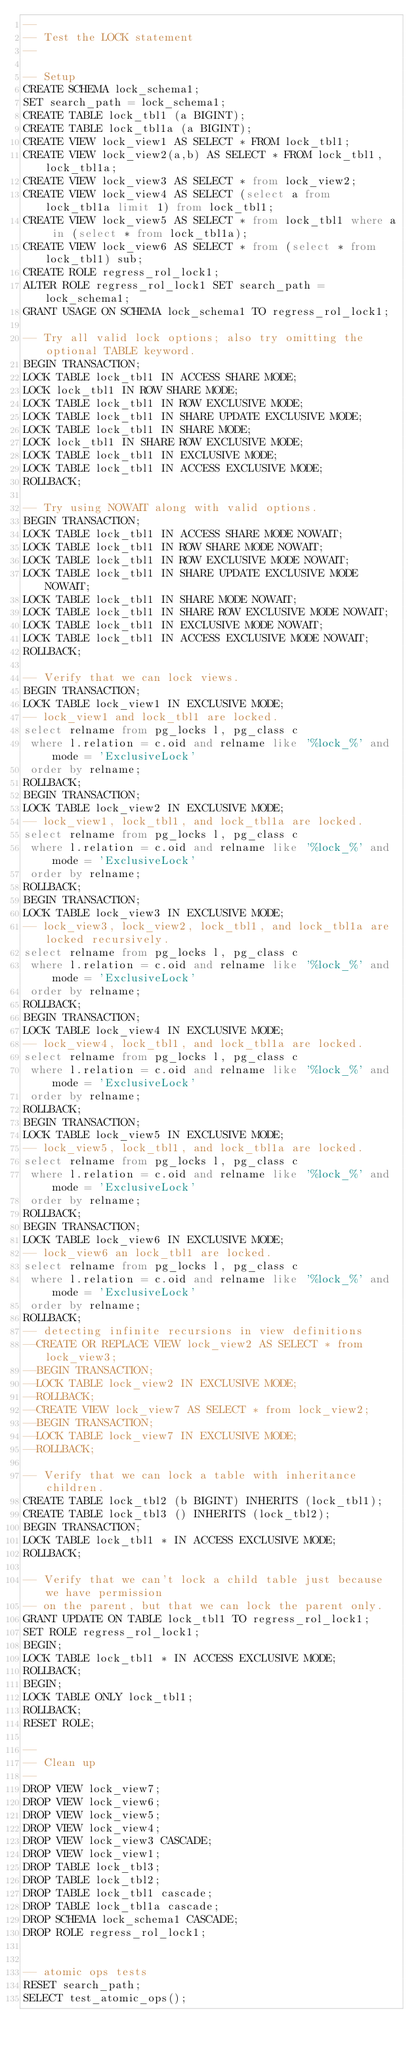Convert code to text. <code><loc_0><loc_0><loc_500><loc_500><_SQL_>--
-- Test the LOCK statement
--

-- Setup
CREATE SCHEMA lock_schema1;
SET search_path = lock_schema1;
CREATE TABLE lock_tbl1 (a BIGINT);
CREATE TABLE lock_tbl1a (a BIGINT);
CREATE VIEW lock_view1 AS SELECT * FROM lock_tbl1;
CREATE VIEW lock_view2(a,b) AS SELECT * FROM lock_tbl1, lock_tbl1a;
CREATE VIEW lock_view3 AS SELECT * from lock_view2;
CREATE VIEW lock_view4 AS SELECT (select a from lock_tbl1a limit 1) from lock_tbl1;
CREATE VIEW lock_view5 AS SELECT * from lock_tbl1 where a in (select * from lock_tbl1a);
CREATE VIEW lock_view6 AS SELECT * from (select * from lock_tbl1) sub;
CREATE ROLE regress_rol_lock1;
ALTER ROLE regress_rol_lock1 SET search_path = lock_schema1;
GRANT USAGE ON SCHEMA lock_schema1 TO regress_rol_lock1;

-- Try all valid lock options; also try omitting the optional TABLE keyword.
BEGIN TRANSACTION;
LOCK TABLE lock_tbl1 IN ACCESS SHARE MODE;
LOCK lock_tbl1 IN ROW SHARE MODE;
LOCK TABLE lock_tbl1 IN ROW EXCLUSIVE MODE;
LOCK TABLE lock_tbl1 IN SHARE UPDATE EXCLUSIVE MODE;
LOCK TABLE lock_tbl1 IN SHARE MODE;
LOCK lock_tbl1 IN SHARE ROW EXCLUSIVE MODE;
LOCK TABLE lock_tbl1 IN EXCLUSIVE MODE;
LOCK TABLE lock_tbl1 IN ACCESS EXCLUSIVE MODE;
ROLLBACK;

-- Try using NOWAIT along with valid options.
BEGIN TRANSACTION;
LOCK TABLE lock_tbl1 IN ACCESS SHARE MODE NOWAIT;
LOCK TABLE lock_tbl1 IN ROW SHARE MODE NOWAIT;
LOCK TABLE lock_tbl1 IN ROW EXCLUSIVE MODE NOWAIT;
LOCK TABLE lock_tbl1 IN SHARE UPDATE EXCLUSIVE MODE NOWAIT;
LOCK TABLE lock_tbl1 IN SHARE MODE NOWAIT;
LOCK TABLE lock_tbl1 IN SHARE ROW EXCLUSIVE MODE NOWAIT;
LOCK TABLE lock_tbl1 IN EXCLUSIVE MODE NOWAIT;
LOCK TABLE lock_tbl1 IN ACCESS EXCLUSIVE MODE NOWAIT;
ROLLBACK;

-- Verify that we can lock views.
BEGIN TRANSACTION;
LOCK TABLE lock_view1 IN EXCLUSIVE MODE;
-- lock_view1 and lock_tbl1 are locked.
select relname from pg_locks l, pg_class c
 where l.relation = c.oid and relname like '%lock_%' and mode = 'ExclusiveLock'
 order by relname;
ROLLBACK;
BEGIN TRANSACTION;
LOCK TABLE lock_view2 IN EXCLUSIVE MODE;
-- lock_view1, lock_tbl1, and lock_tbl1a are locked.
select relname from pg_locks l, pg_class c
 where l.relation = c.oid and relname like '%lock_%' and mode = 'ExclusiveLock'
 order by relname;
ROLLBACK;
BEGIN TRANSACTION;
LOCK TABLE lock_view3 IN EXCLUSIVE MODE;
-- lock_view3, lock_view2, lock_tbl1, and lock_tbl1a are locked recursively.
select relname from pg_locks l, pg_class c
 where l.relation = c.oid and relname like '%lock_%' and mode = 'ExclusiveLock'
 order by relname;
ROLLBACK;
BEGIN TRANSACTION;
LOCK TABLE lock_view4 IN EXCLUSIVE MODE;
-- lock_view4, lock_tbl1, and lock_tbl1a are locked.
select relname from pg_locks l, pg_class c
 where l.relation = c.oid and relname like '%lock_%' and mode = 'ExclusiveLock'
 order by relname;
ROLLBACK;
BEGIN TRANSACTION;
LOCK TABLE lock_view5 IN EXCLUSIVE MODE;
-- lock_view5, lock_tbl1, and lock_tbl1a are locked.
select relname from pg_locks l, pg_class c
 where l.relation = c.oid and relname like '%lock_%' and mode = 'ExclusiveLock'
 order by relname;
ROLLBACK;
BEGIN TRANSACTION;
LOCK TABLE lock_view6 IN EXCLUSIVE MODE;
-- lock_view6 an lock_tbl1 are locked.
select relname from pg_locks l, pg_class c
 where l.relation = c.oid and relname like '%lock_%' and mode = 'ExclusiveLock'
 order by relname;
ROLLBACK;
-- detecting infinite recursions in view definitions
--CREATE OR REPLACE VIEW lock_view2 AS SELECT * from lock_view3;
--BEGIN TRANSACTION;
--LOCK TABLE lock_view2 IN EXCLUSIVE MODE;
--ROLLBACK;
--CREATE VIEW lock_view7 AS SELECT * from lock_view2;
--BEGIN TRANSACTION;
--LOCK TABLE lock_view7 IN EXCLUSIVE MODE;
--ROLLBACK;

-- Verify that we can lock a table with inheritance children.
CREATE TABLE lock_tbl2 (b BIGINT) INHERITS (lock_tbl1);
CREATE TABLE lock_tbl3 () INHERITS (lock_tbl2);
BEGIN TRANSACTION;
LOCK TABLE lock_tbl1 * IN ACCESS EXCLUSIVE MODE;
ROLLBACK;

-- Verify that we can't lock a child table just because we have permission
-- on the parent, but that we can lock the parent only.
GRANT UPDATE ON TABLE lock_tbl1 TO regress_rol_lock1;
SET ROLE regress_rol_lock1;
BEGIN;
LOCK TABLE lock_tbl1 * IN ACCESS EXCLUSIVE MODE;
ROLLBACK;
BEGIN;
LOCK TABLE ONLY lock_tbl1;
ROLLBACK;
RESET ROLE;

--
-- Clean up
--
DROP VIEW lock_view7;
DROP VIEW lock_view6;
DROP VIEW lock_view5;
DROP VIEW lock_view4;
DROP VIEW lock_view3 CASCADE;
DROP VIEW lock_view1;
DROP TABLE lock_tbl3;
DROP TABLE lock_tbl2;
DROP TABLE lock_tbl1 cascade;
DROP TABLE lock_tbl1a cascade;
DROP SCHEMA lock_schema1 CASCADE;
DROP ROLE regress_rol_lock1;


-- atomic ops tests
RESET search_path;
SELECT test_atomic_ops();
</code> 